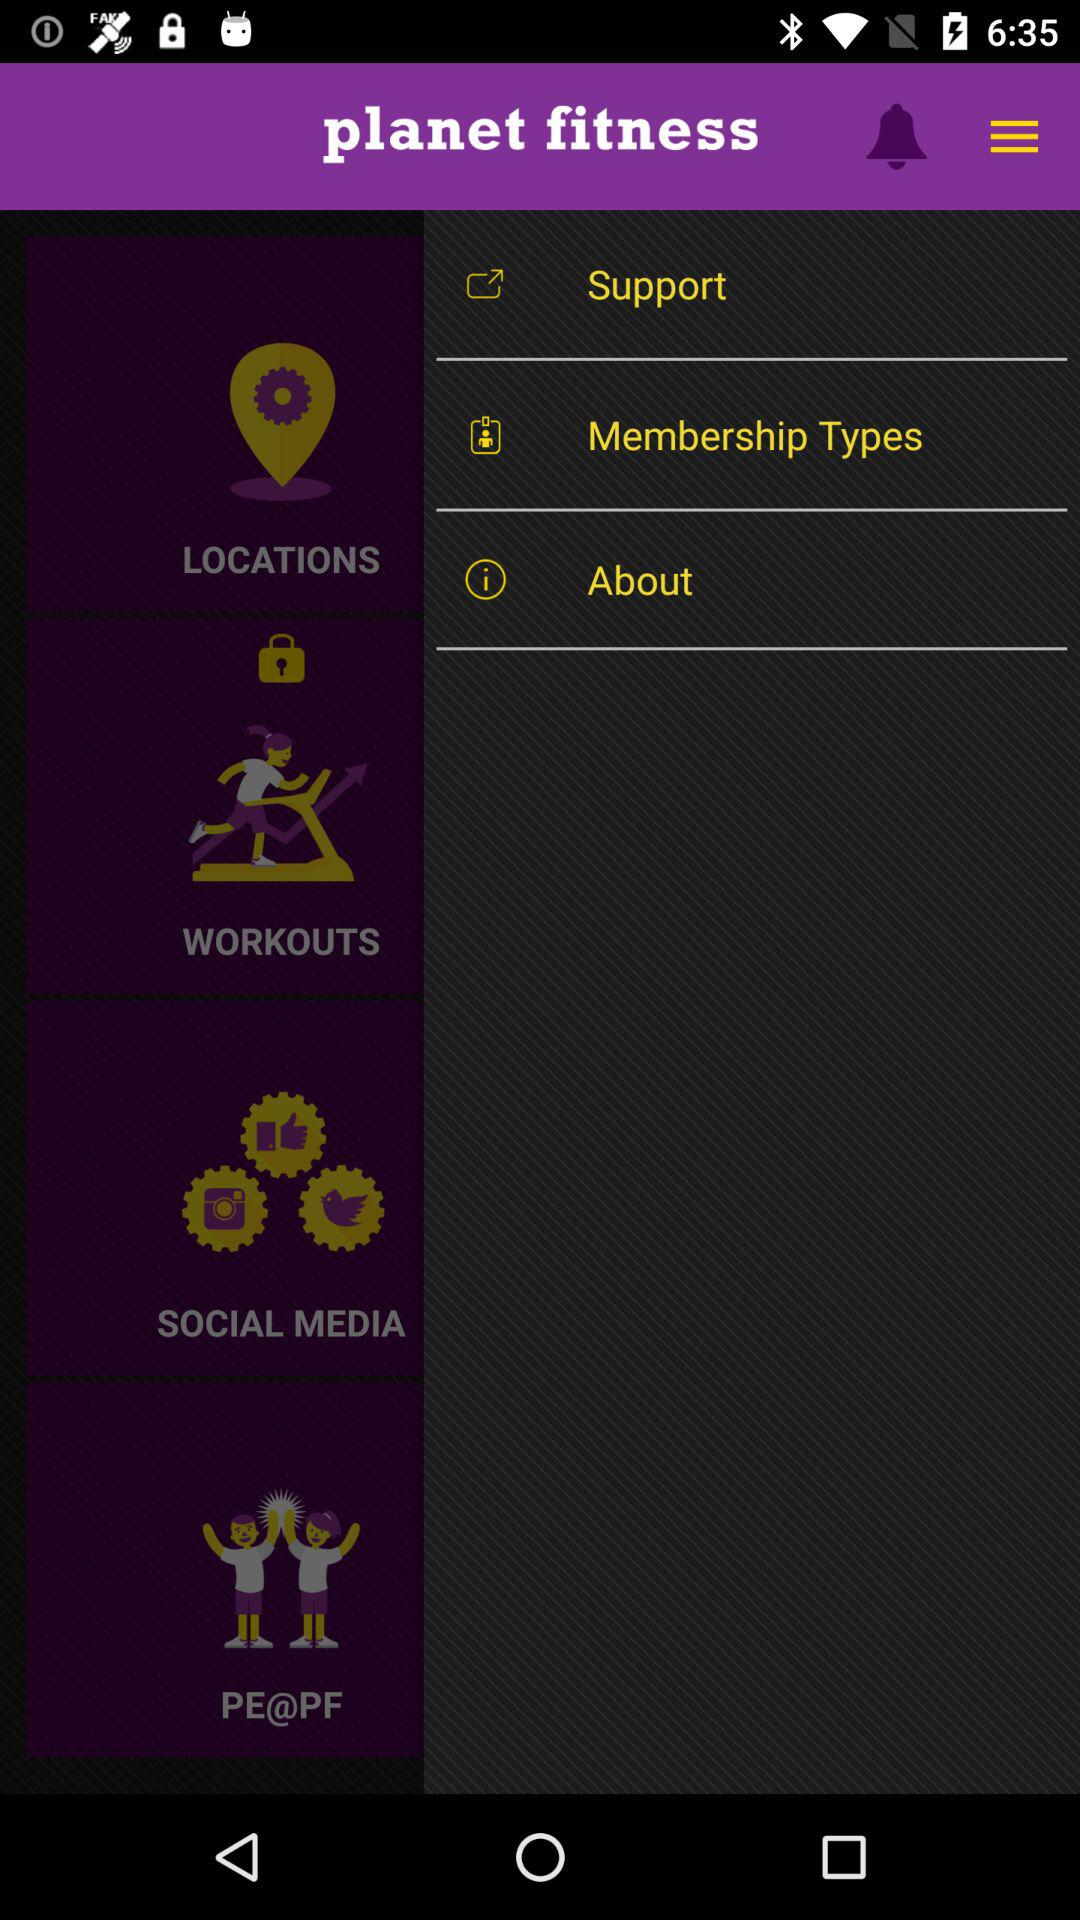What is the application name? The application name is "planet fitness". 